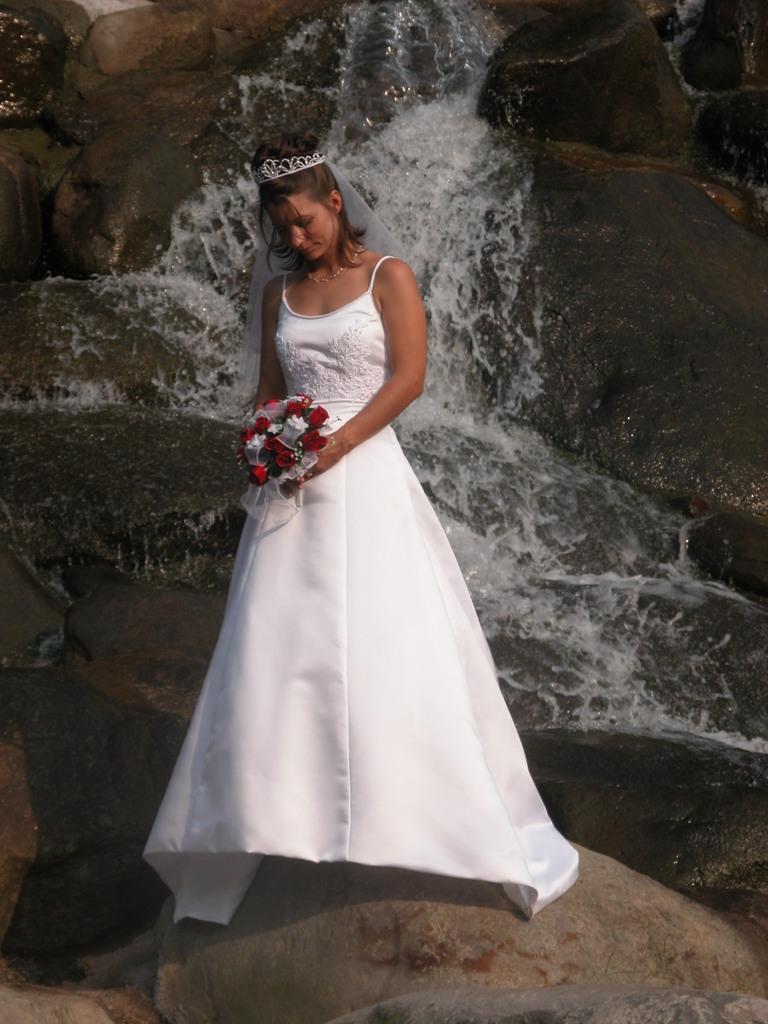How would you summarize this image in a sentence or two? In this image we can see a person holding an object. Behind the person we can see water and rocks. 